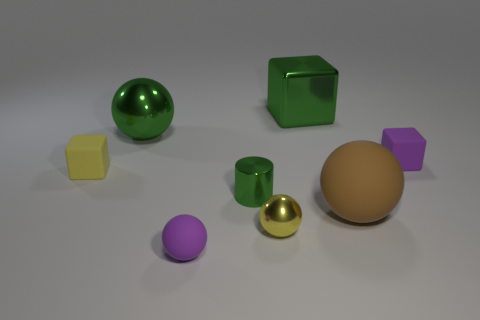Does the large rubber sphere have the same color as the metallic block?
Your response must be concise. No. There is a purple cube that is made of the same material as the brown thing; what size is it?
Offer a very short reply. Small. What color is the object that is to the right of the green block and behind the brown thing?
Provide a short and direct response. Purple. What size is the rubber block that is the same color as the tiny shiny sphere?
Offer a very short reply. Small. There is a shiny object that is both behind the brown sphere and on the right side of the green cylinder; what size is it?
Provide a short and direct response. Large. What number of small purple rubber things are left of the block that is to the right of the brown matte sphere to the right of the yellow cube?
Your answer should be compact. 1. There is a rubber object that is the same size as the green metal sphere; what is its color?
Offer a very short reply. Brown. What is the shape of the purple object left of the rubber block to the right of the large sphere behind the tiny yellow rubber block?
Your answer should be compact. Sphere. Does the purple thing that is left of the metallic cylinder have the same shape as the small purple matte thing to the right of the tiny yellow sphere?
Your response must be concise. No. What number of things are green objects or purple cubes?
Make the answer very short. 4. 